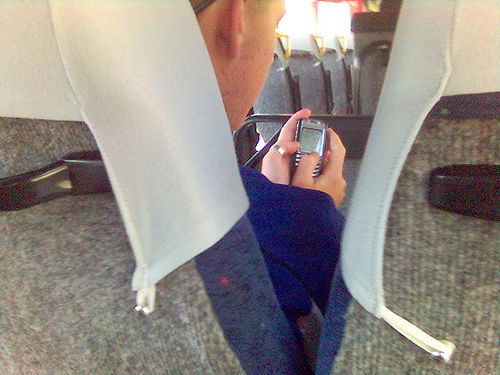<image>Would this be a male or female? I don't know if this is a male or female. What is this person thinking? It is unknown what this person is thinking. Would this be a male or female? It is not possible to determine whether this would be a male or female. What is this person thinking? I don't know what this person is thinking. It could be any of the given options. 